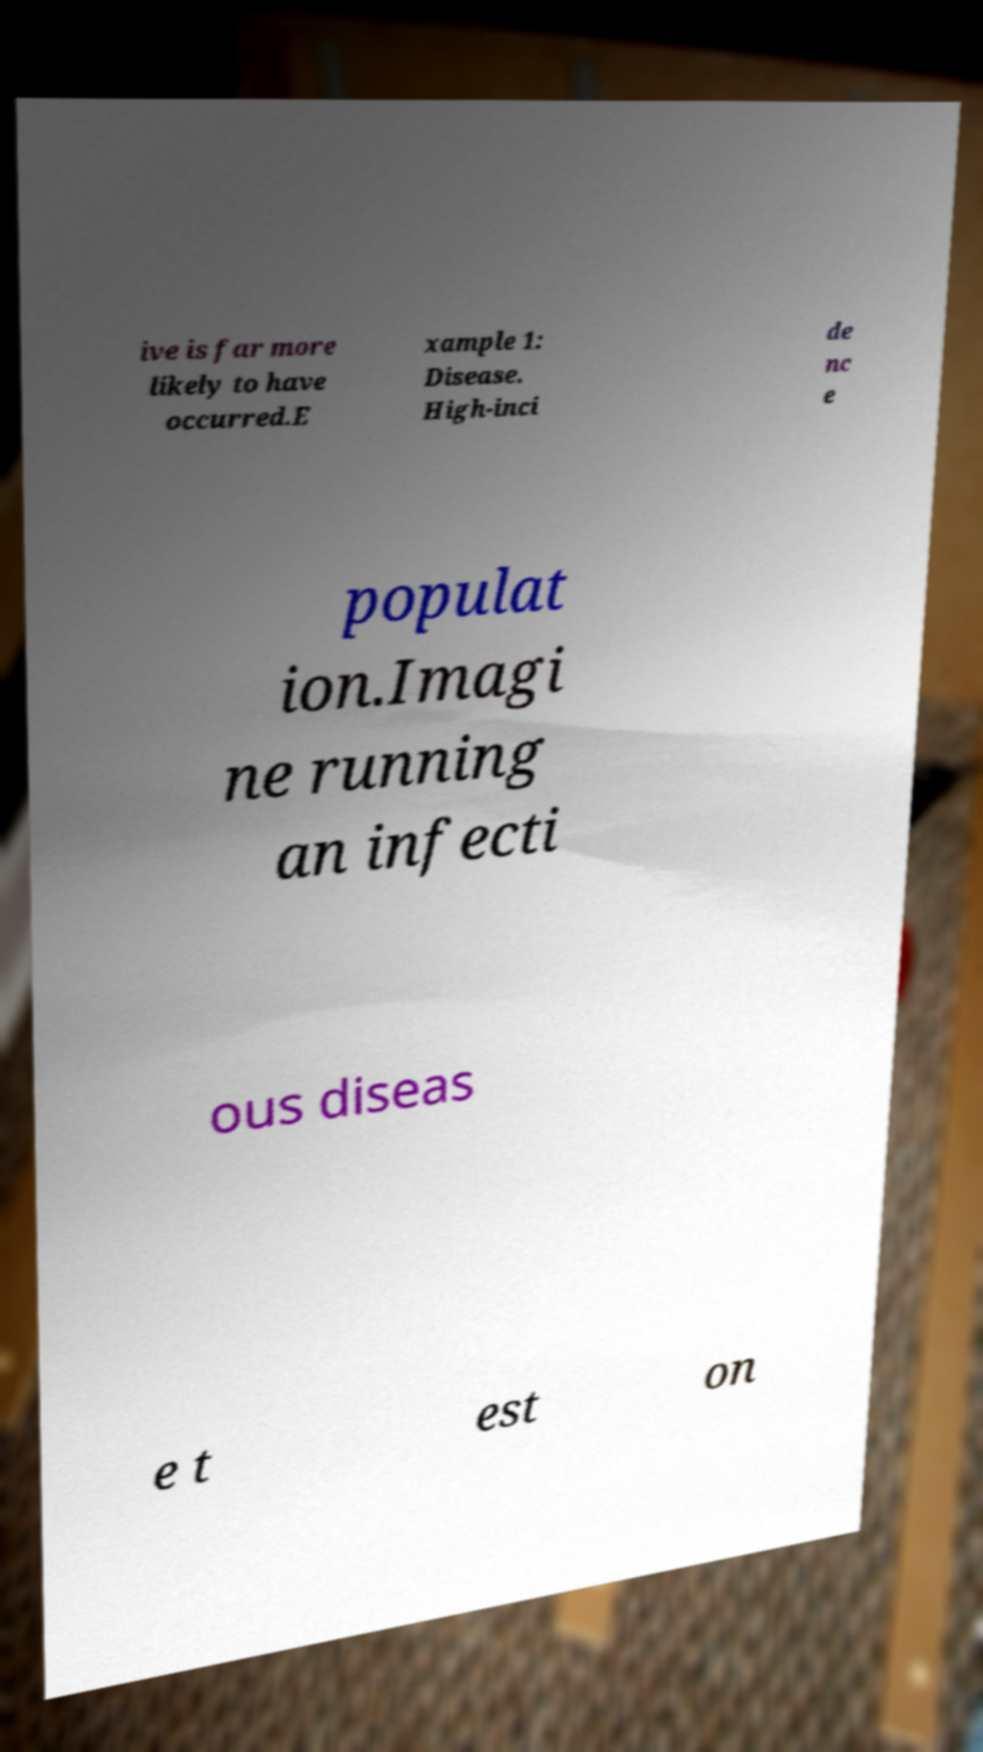Can you accurately transcribe the text from the provided image for me? ive is far more likely to have occurred.E xample 1: Disease. High-inci de nc e populat ion.Imagi ne running an infecti ous diseas e t est on 